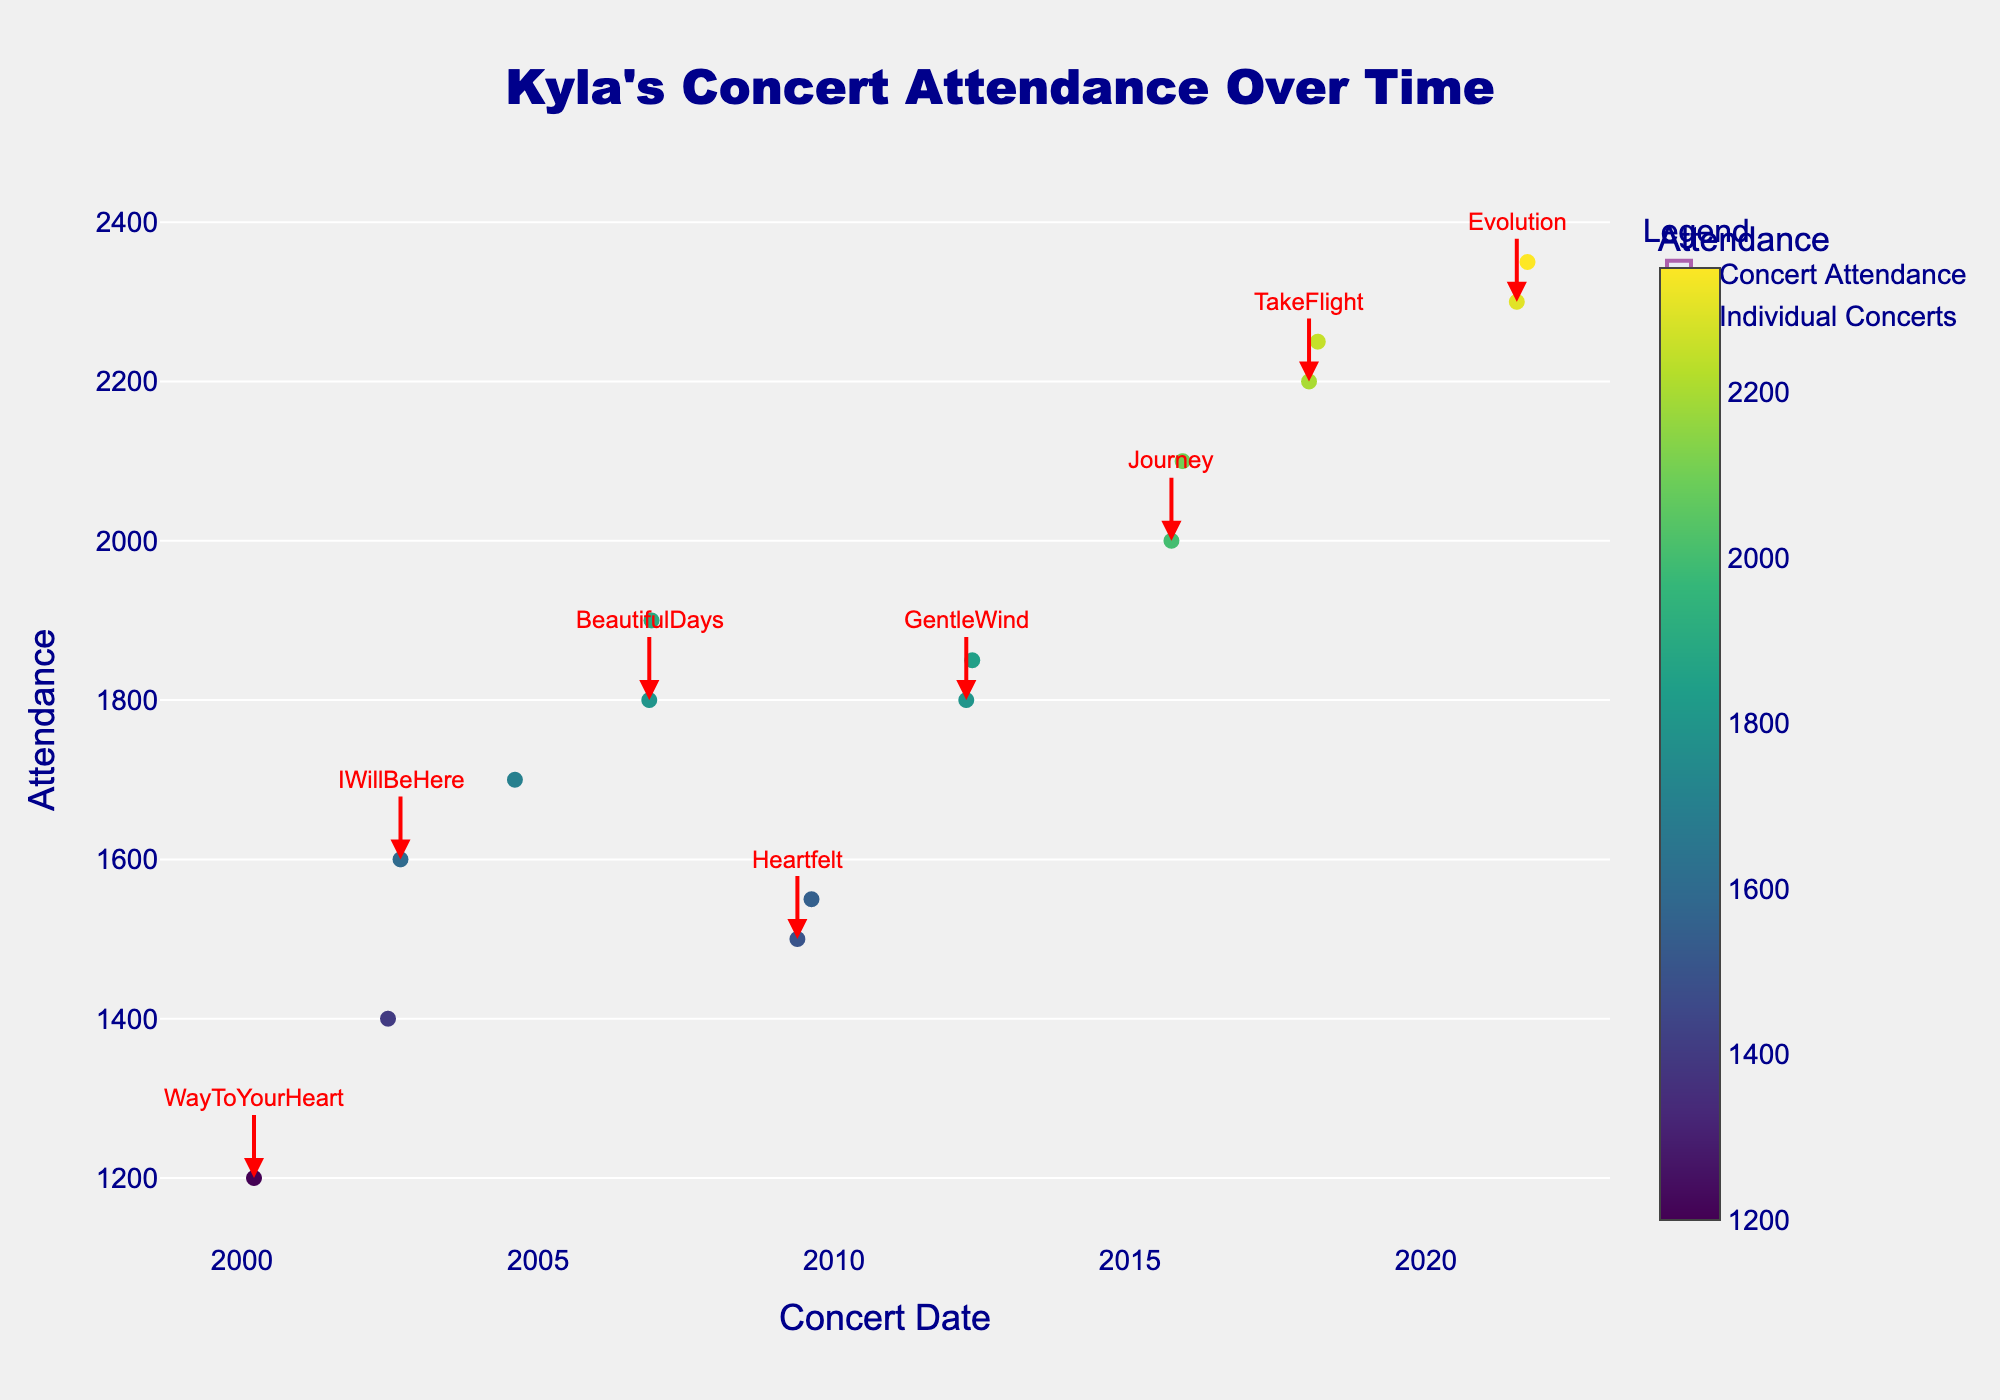What's the title of the plot? The title is typically displayed at the top of the plot and is used to summarize the content being visualized. Here, the title can be read directly from the plot.
Answer: Kyla's Concert Attendance Over Time What are the units used for the y-axis? The y-axis shows the measurement unit, which can be identified by looking at the axis label on the plot. In this case, it refers to the number of attendees.
Answer: Attendance How many concert attendance data points are there? To determine the number of attendance data points, you can count the individual markers on the plot.
Answer: 16 Which year had the highest concert attendance? To find the highest attendance year, look for the peak points on the y-axis in the plot and note the corresponding year. The highest attendance is around September 2021.
Answer: 2021 Compare the concert attendance before and after the release of the "BeautifulDays" album. Which period had higher attendance? Look at the plot to identify the attendances just before and after the "BeautifulDays" release (2006-11-18 and 2006-12-02). Compare the attendance values to see which is higher.
Answer: After At what concert date did Kyla have an attendance of 2250? Locate the y-axis value of 2250 on the plot and trace it horizontally to find the corresponding concert date at that level, which is in early 2018.
Answer: 2018-03-05 How does the average attendance in the "GentleWind" album era compare to the average attendance in the "TakeFlight" album era? Calculate the mean attendance values for the concerts around the release periods of "GentleWind" (2012) and "TakeFlight" (2018), and then compare these averages. GentleWind: (1800 + 1850)/2 = 1825, TakeFlight: (2200 + 2250)/2 = 2225.
Answer: TakeFlight has higher average attendance Identify the date range during which the "Heartfelt" concerts occurred, and describe the trend in attendance. Look at the plot to identify the dates associated with "Heartfelt" (2009-05-20 and 2009-08-15) and observe whether the attendances were increasing, decreasing, or steady.
Answer: From May 2009 to August 2009, with a slight increase Was there any overlap in concert dates among different album releases? Trace the concert dates provided on the plot to see if any share the same dates or are close together within different album release periods.
Answer: No overlap 